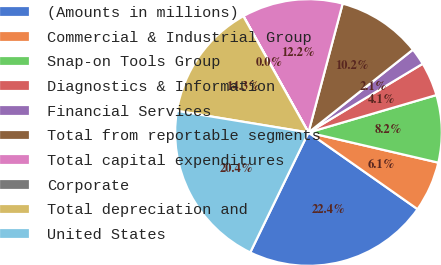Convert chart. <chart><loc_0><loc_0><loc_500><loc_500><pie_chart><fcel>(Amounts in millions)<fcel>Commercial & Industrial Group<fcel>Snap-on Tools Group<fcel>Diagnostics & Information<fcel>Financial Services<fcel>Total from reportable segments<fcel>Total capital expenditures<fcel>Corporate<fcel>Total depreciation and<fcel>United States<nl><fcel>22.44%<fcel>6.12%<fcel>8.16%<fcel>4.09%<fcel>2.05%<fcel>10.2%<fcel>12.24%<fcel>0.01%<fcel>14.28%<fcel>20.4%<nl></chart> 